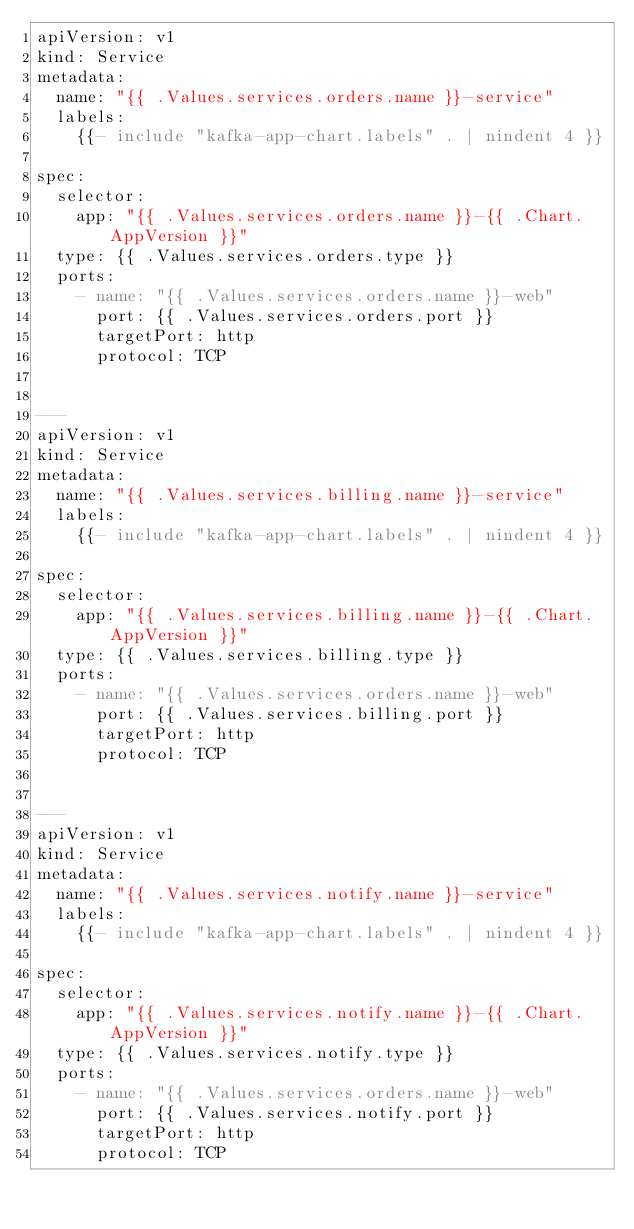Convert code to text. <code><loc_0><loc_0><loc_500><loc_500><_YAML_>apiVersion: v1
kind: Service
metadata:
  name: "{{ .Values.services.orders.name }}-service"
  labels:
    {{- include "kafka-app-chart.labels" . | nindent 4 }}

spec:
  selector:
    app: "{{ .Values.services.orders.name }}-{{ .Chart.AppVersion }}"
  type: {{ .Values.services.orders.type }}
  ports:
    - name: "{{ .Values.services.orders.name }}-web"
      port: {{ .Values.services.orders.port }}
      targetPort: http
      protocol: TCP


---
apiVersion: v1
kind: Service
metadata:
  name: "{{ .Values.services.billing.name }}-service"
  labels:
    {{- include "kafka-app-chart.labels" . | nindent 4 }}

spec:
  selector:
    app: "{{ .Values.services.billing.name }}-{{ .Chart.AppVersion }}"
  type: {{ .Values.services.billing.type }}
  ports:
    - name: "{{ .Values.services.orders.name }}-web"
      port: {{ .Values.services.billing.port }}
      targetPort: http
      protocol: TCP


---
apiVersion: v1
kind: Service
metadata:
  name: "{{ .Values.services.notify.name }}-service"
  labels:
    {{- include "kafka-app-chart.labels" . | nindent 4 }}

spec:
  selector:
    app: "{{ .Values.services.notify.name }}-{{ .Chart.AppVersion }}"
  type: {{ .Values.services.notify.type }}
  ports:
    - name: "{{ .Values.services.orders.name }}-web"
      port: {{ .Values.services.notify.port }}
      targetPort: http
      protocol: TCP
</code> 